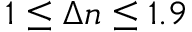Convert formula to latex. <formula><loc_0><loc_0><loc_500><loc_500>1 \leq \Delta n \leq 1 . 9</formula> 